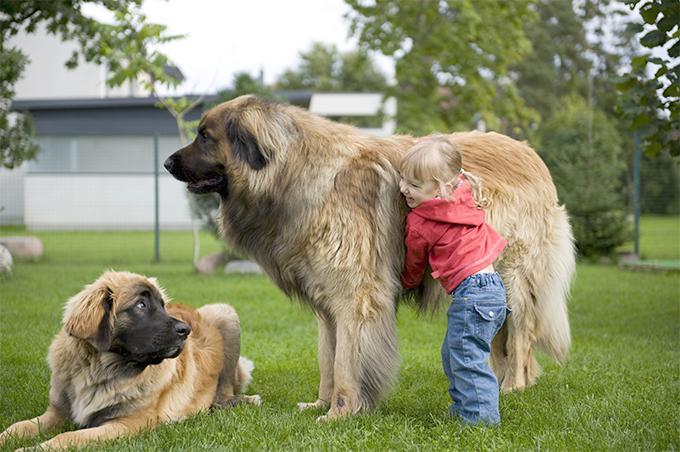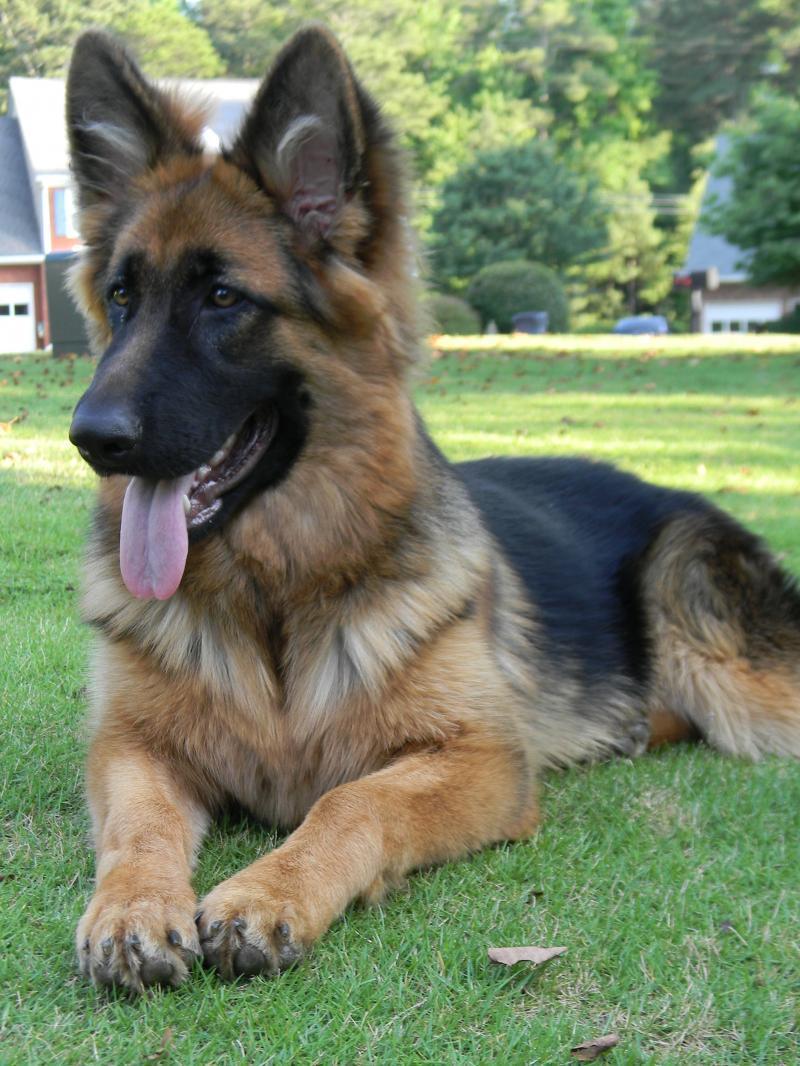The first image is the image on the left, the second image is the image on the right. Evaluate the accuracy of this statement regarding the images: "There is a small child playing with a big dog.". Is it true? Answer yes or no. Yes. 